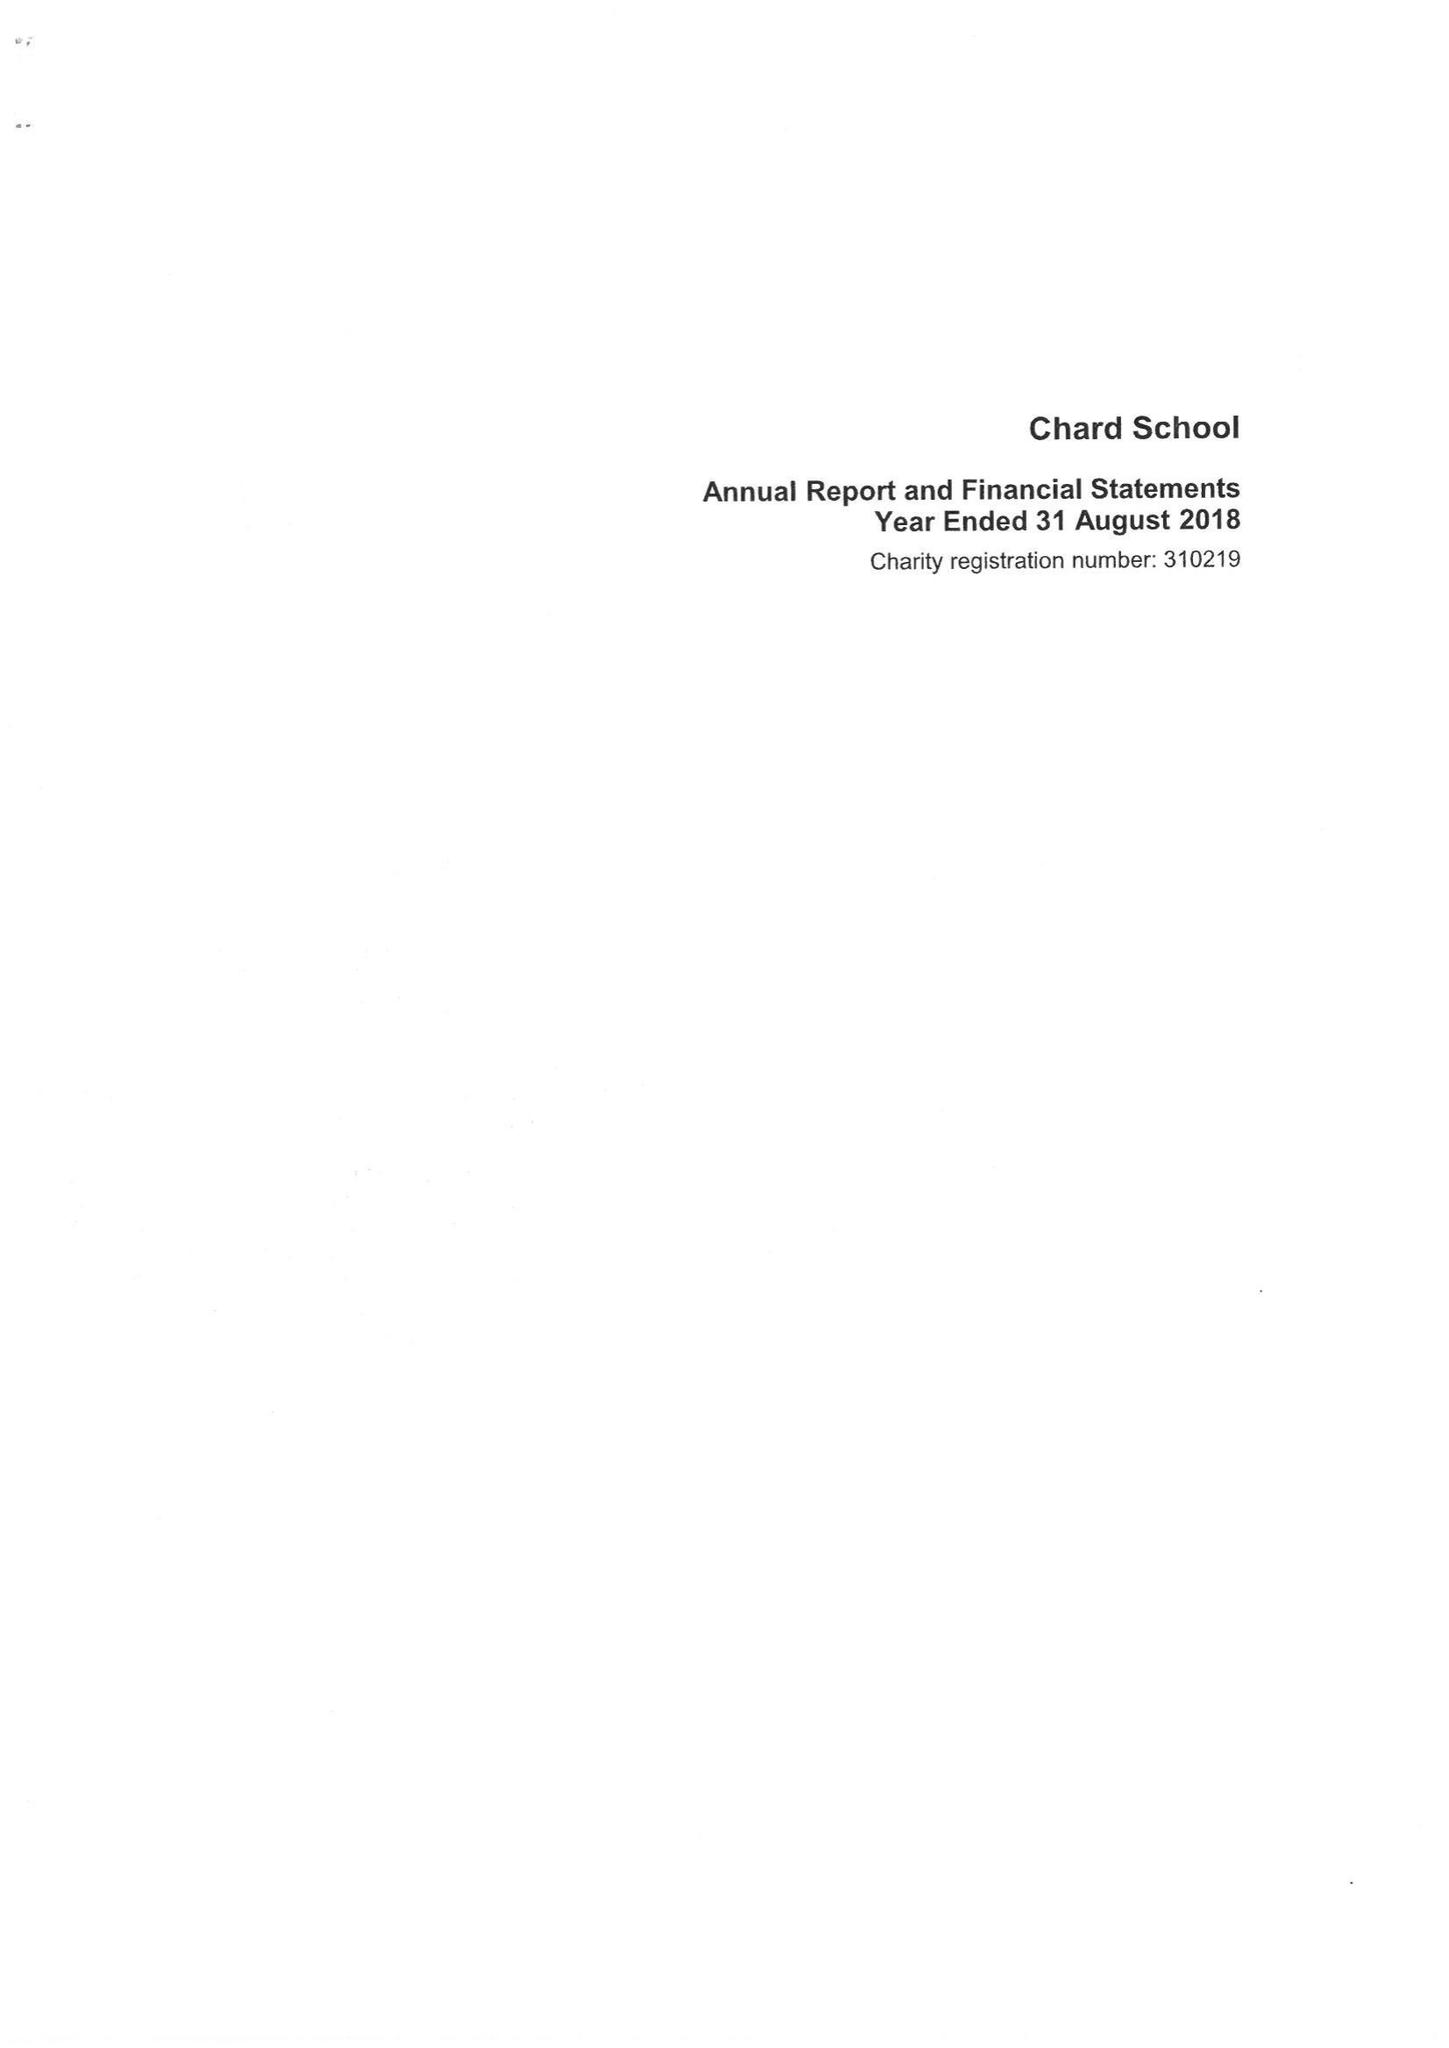What is the value for the report_date?
Answer the question using a single word or phrase. 2018-08-31 